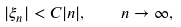<formula> <loc_0><loc_0><loc_500><loc_500>| \xi _ { n } | < C | n | , \quad n \rightarrow \infty ,</formula> 